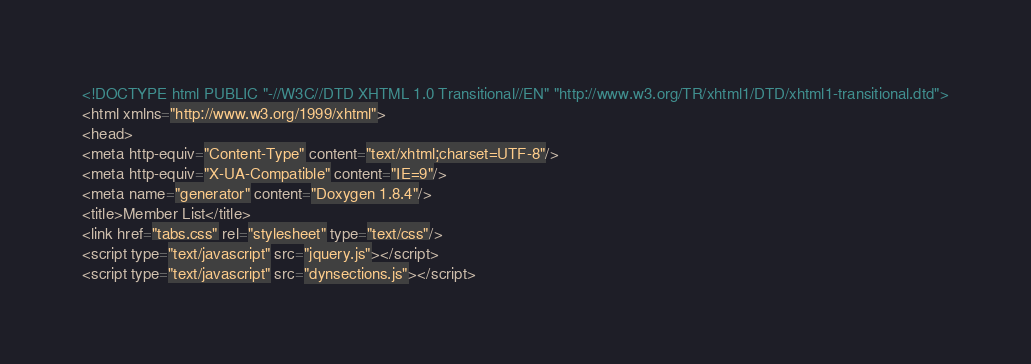<code> <loc_0><loc_0><loc_500><loc_500><_HTML_><!DOCTYPE html PUBLIC "-//W3C//DTD XHTML 1.0 Transitional//EN" "http://www.w3.org/TR/xhtml1/DTD/xhtml1-transitional.dtd">
<html xmlns="http://www.w3.org/1999/xhtml">
<head>
<meta http-equiv="Content-Type" content="text/xhtml;charset=UTF-8"/>
<meta http-equiv="X-UA-Compatible" content="IE=9"/>
<meta name="generator" content="Doxygen 1.8.4"/>
<title>Member List</title>
<link href="tabs.css" rel="stylesheet" type="text/css"/>
<script type="text/javascript" src="jquery.js"></script>
<script type="text/javascript" src="dynsections.js"></script></code> 